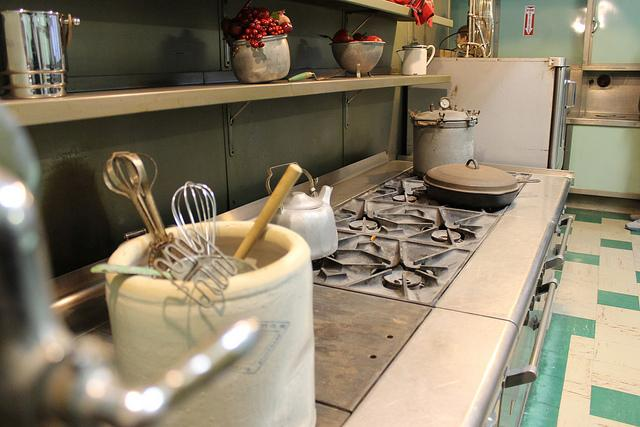What could the pot with the round white gauge on top be used for?

Choices:
A) baking bread
B) canning fruit
C) making candy
D) peeling carrots canning fruit 